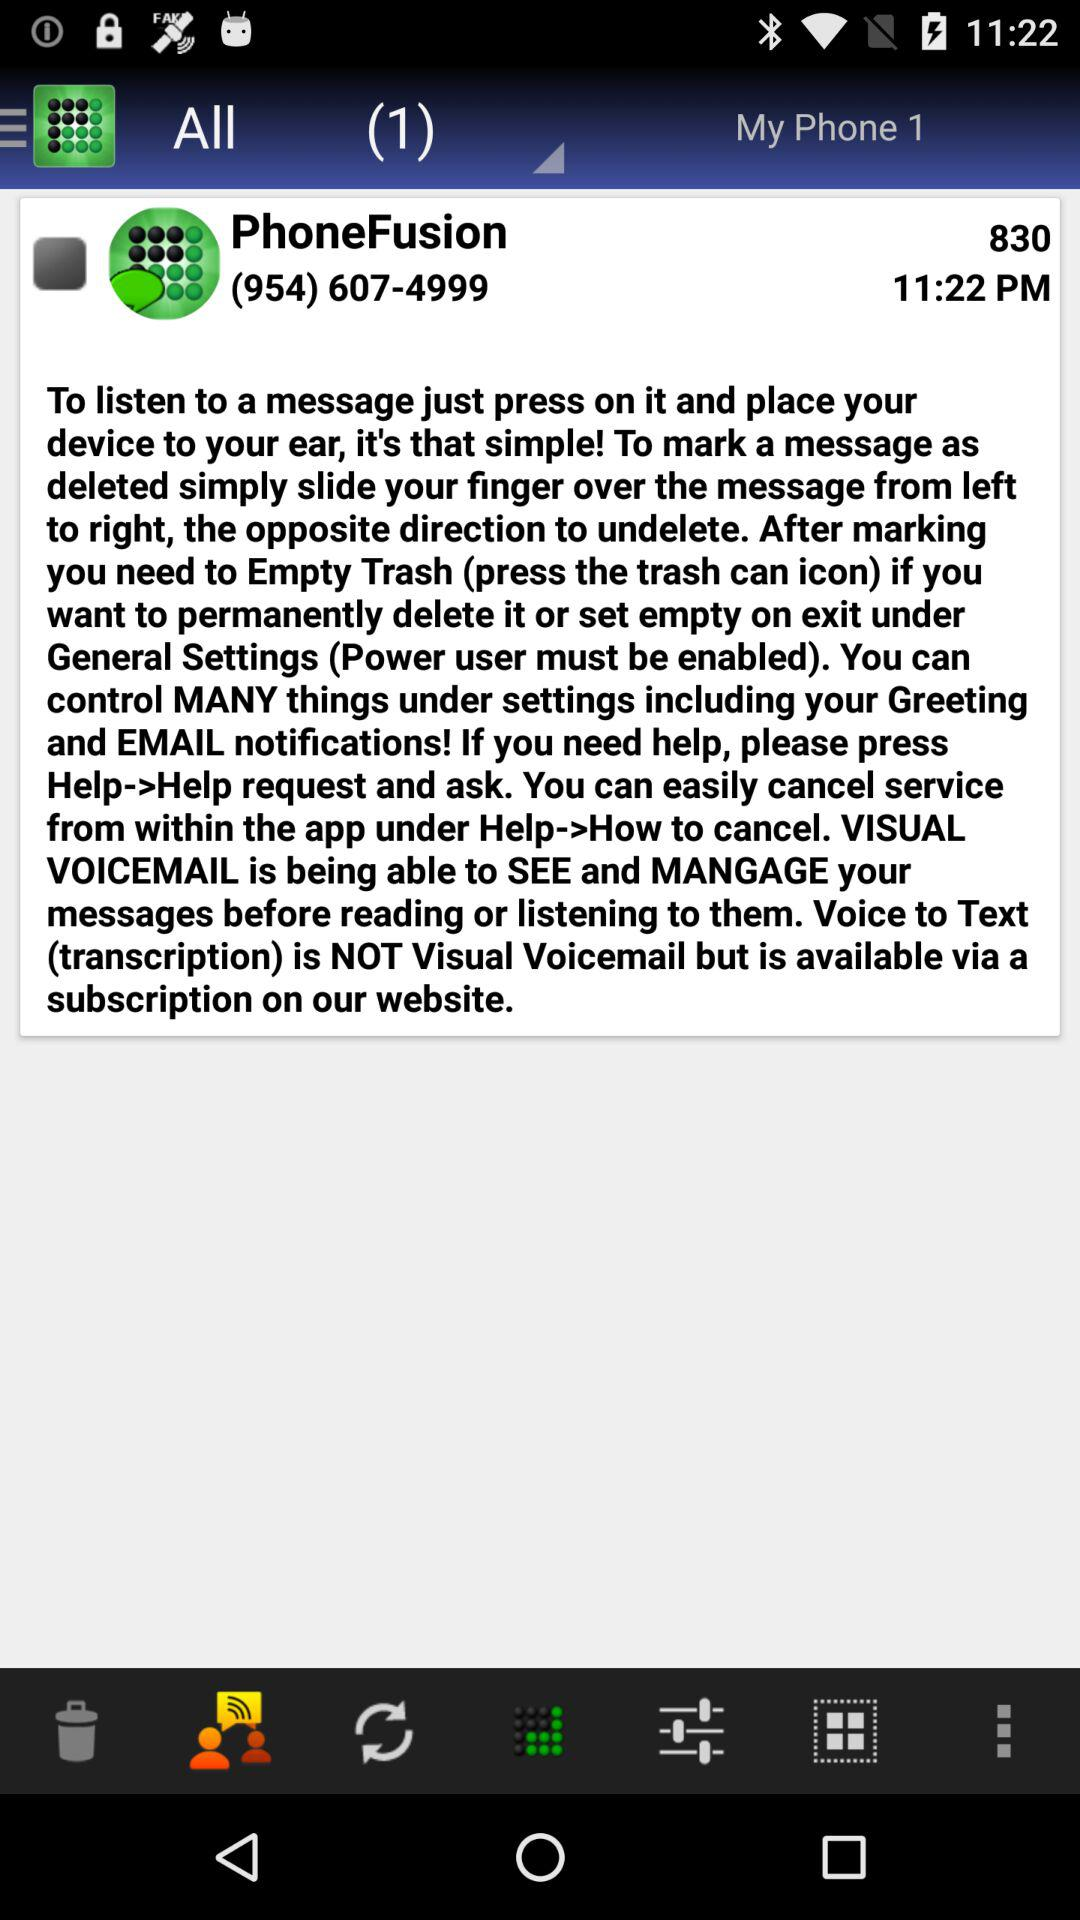What is the phone number? The phone number is (954) 607-4999. 